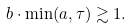<formula> <loc_0><loc_0><loc_500><loc_500>b \cdot \min ( a , \tau ) \gtrsim 1 .</formula> 